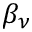Convert formula to latex. <formula><loc_0><loc_0><loc_500><loc_500>\beta _ { \nu }</formula> 